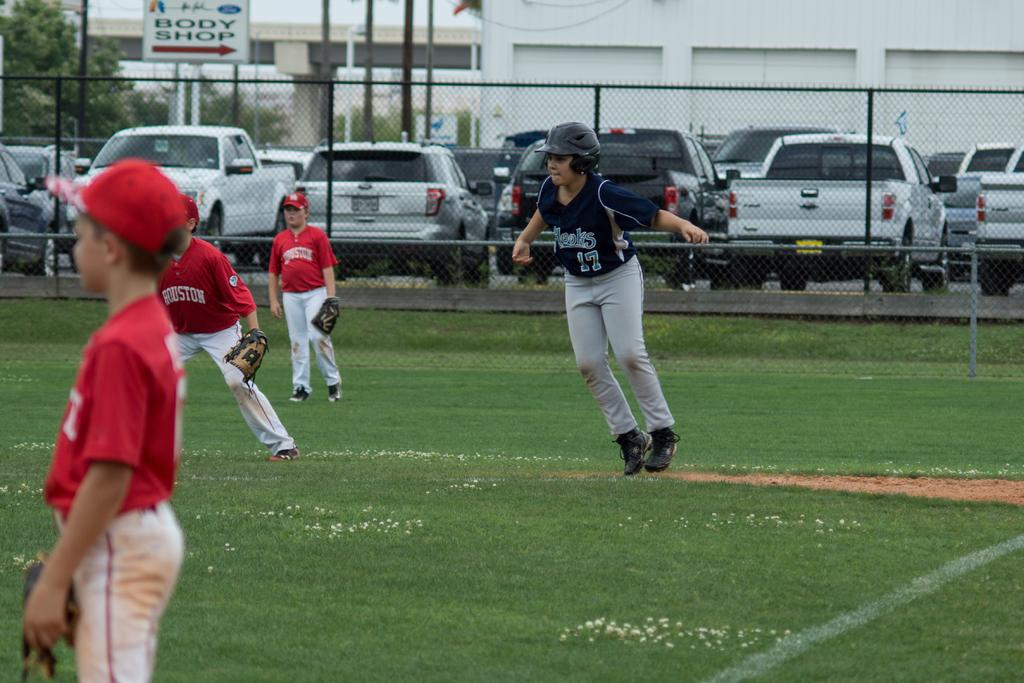<image>
Write a terse but informative summary of the picture. A kids baseball game tkes place next to a sign pointing the way to a body shop. 